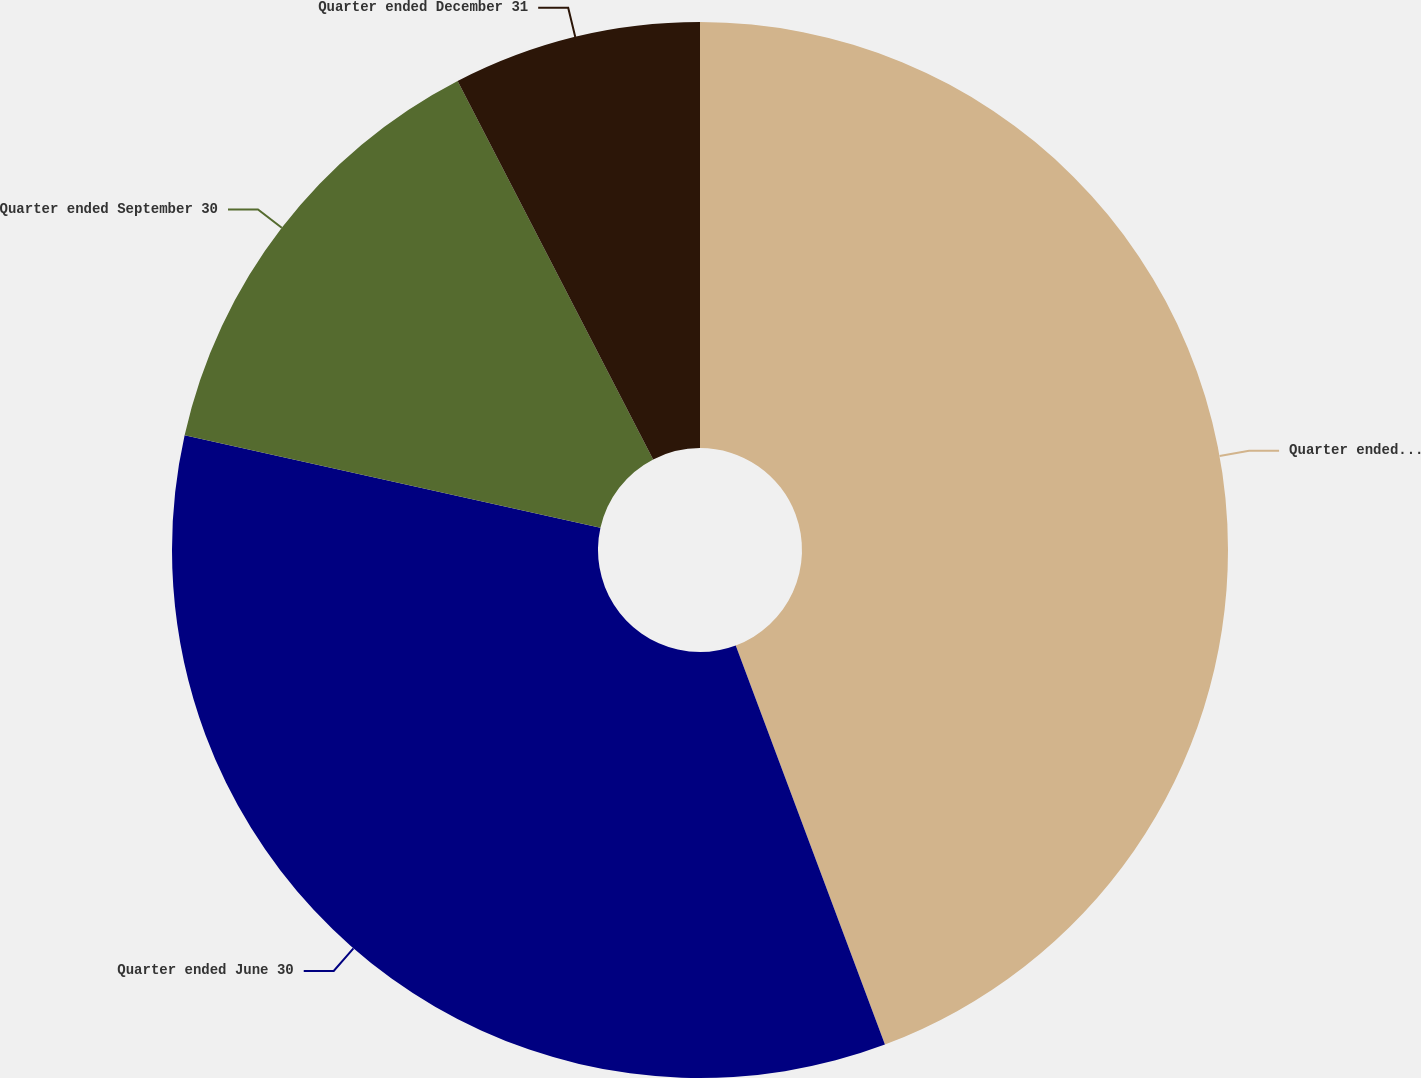Convert chart to OTSL. <chart><loc_0><loc_0><loc_500><loc_500><pie_chart><fcel>Quarter ended March 31<fcel>Quarter ended June 30<fcel>Quarter ended September 30<fcel>Quarter ended December 31<nl><fcel>44.3%<fcel>34.18%<fcel>13.92%<fcel>7.59%<nl></chart> 